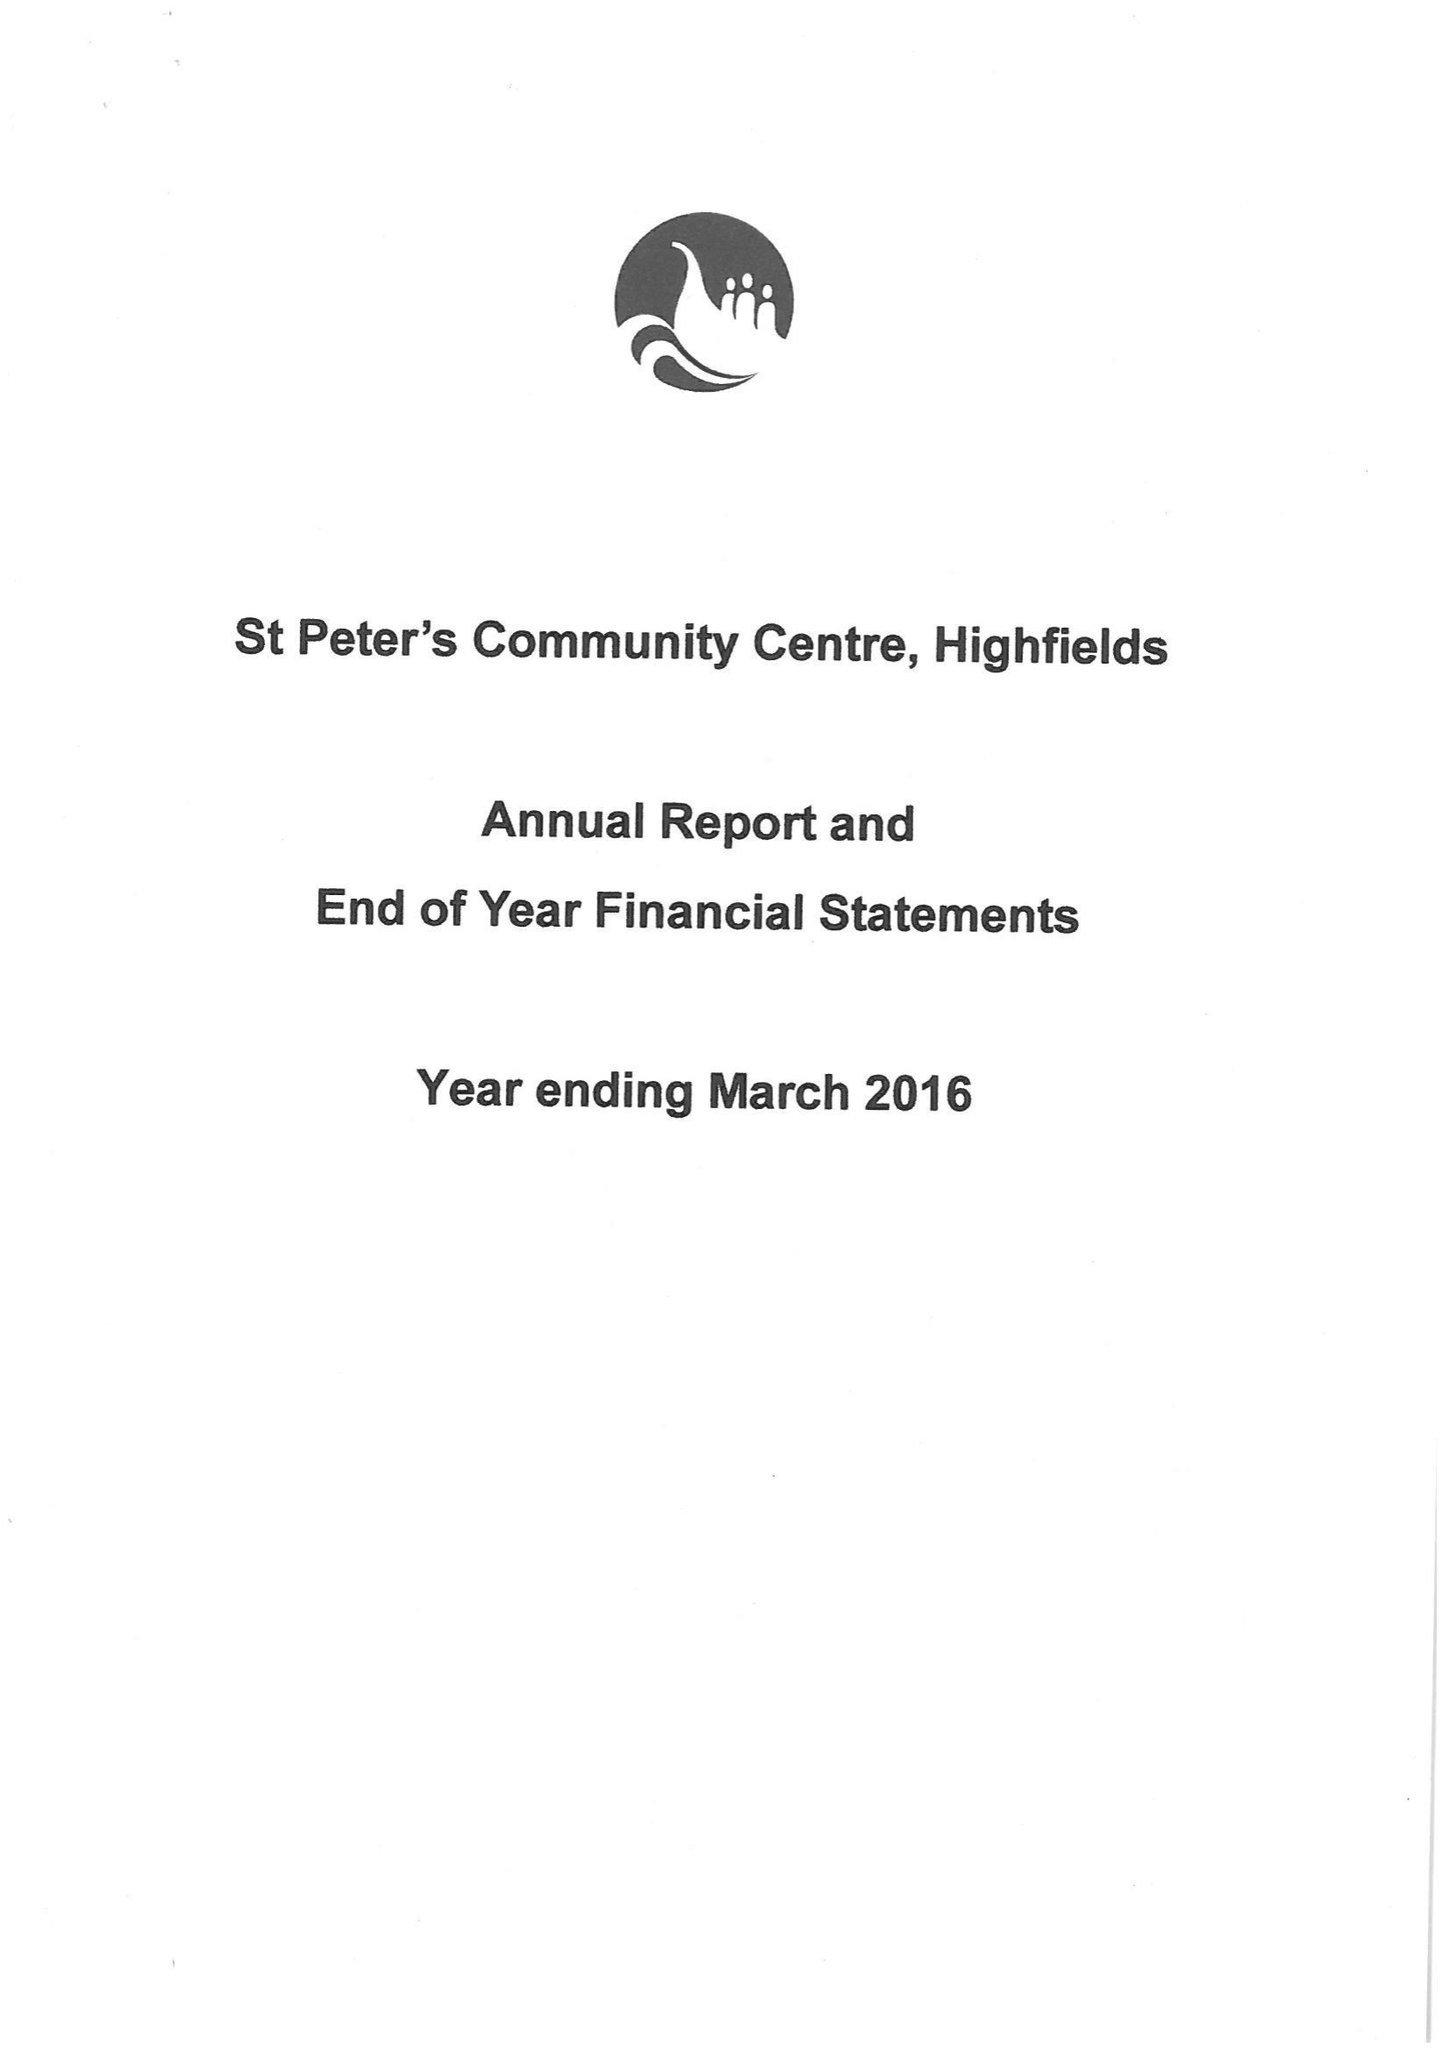What is the value for the address__street_line?
Answer the question using a single word or phrase. None 